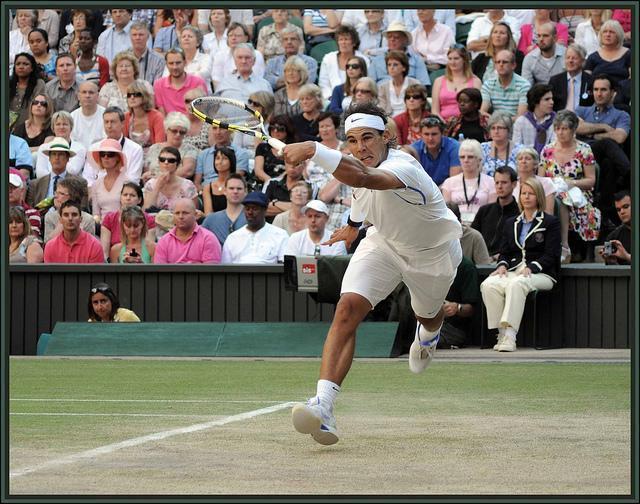What is the player's facial expression?
Answer the question by selecting the correct answer among the 4 following choices and explain your choice with a short sentence. The answer should be formatted with the following format: `Answer: choice
Rationale: rationale.`
Options: Disgusted, focused, angry, painful. Answer: focused.
Rationale: The woman is aimed on getting the ball. 